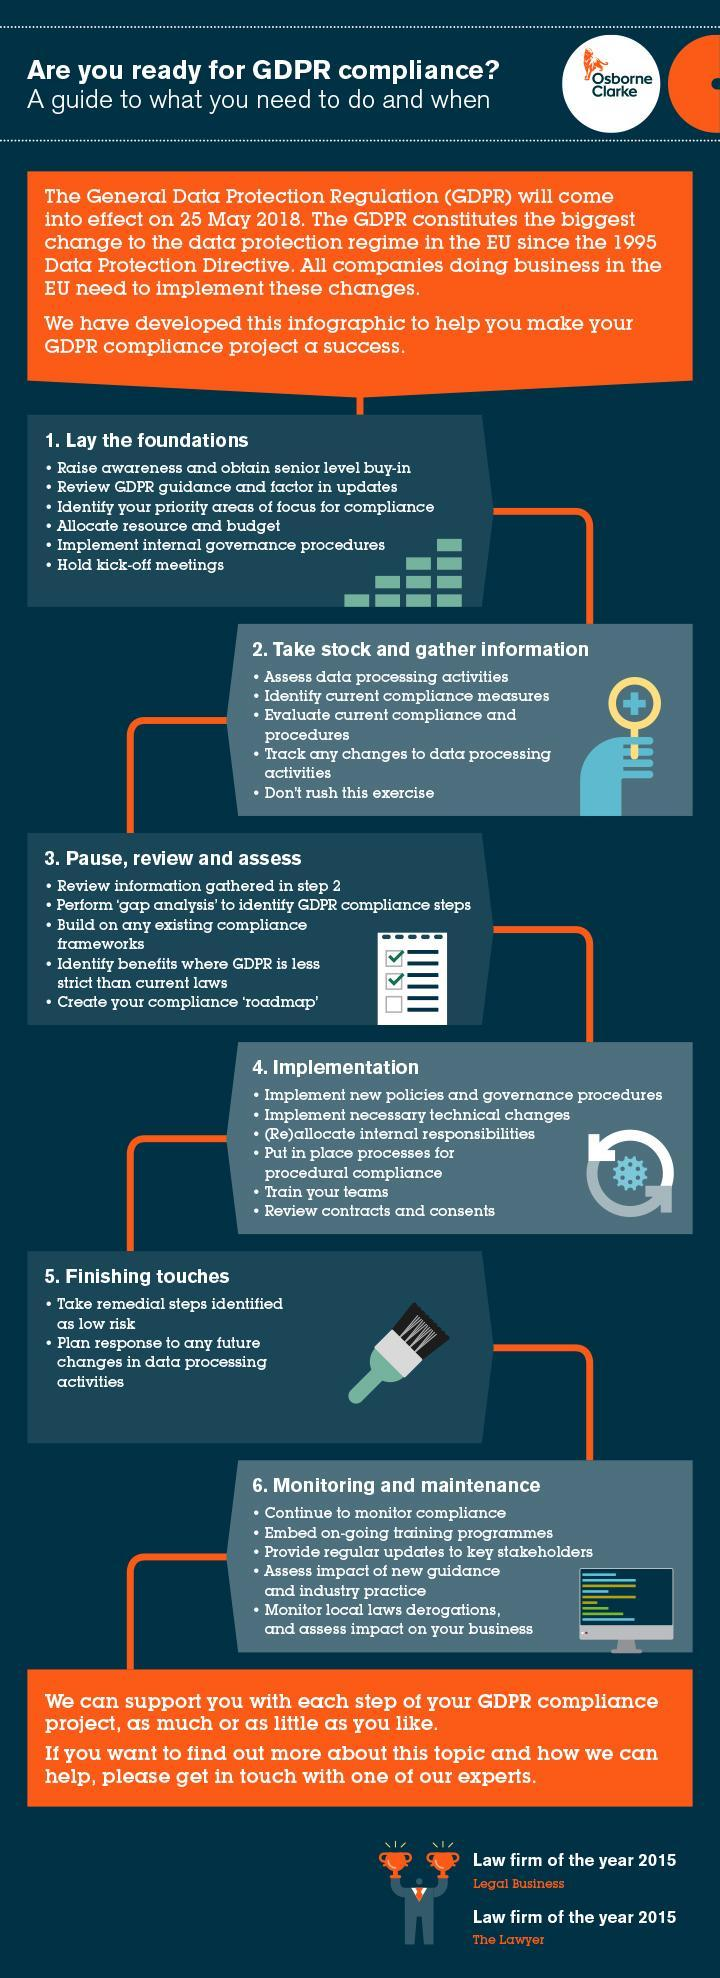What is the first tip mentioned in the finishing touches step?
Answer the question with a short phrase. Take remedial steps identified as low risk What is the second tip mentioned in the laying foundations step? Review GDPR guidance and factor in updates 